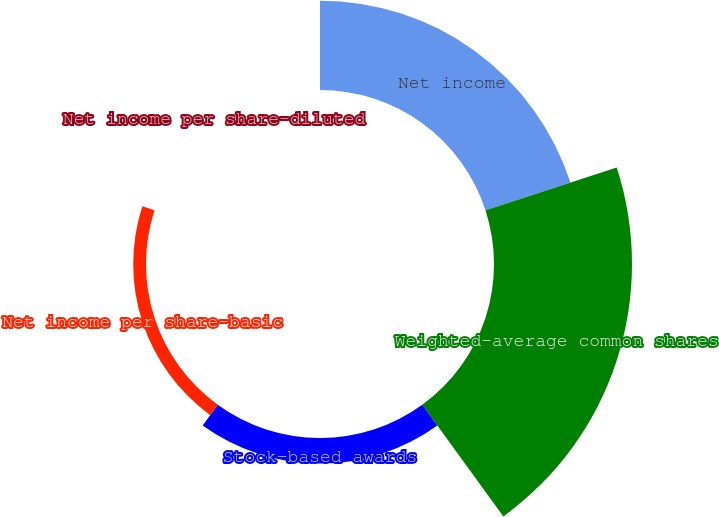Convert chart to OTSL. <chart><loc_0><loc_0><loc_500><loc_500><pie_chart><fcel>Net income<fcel>Weighted-average common shares<fcel>Stock-based awards<fcel>Net income per share-basic<fcel>Net income per share-diluted<nl><fcel>33.62%<fcel>51.92%<fcel>9.64%<fcel>4.82%<fcel>0.0%<nl></chart> 